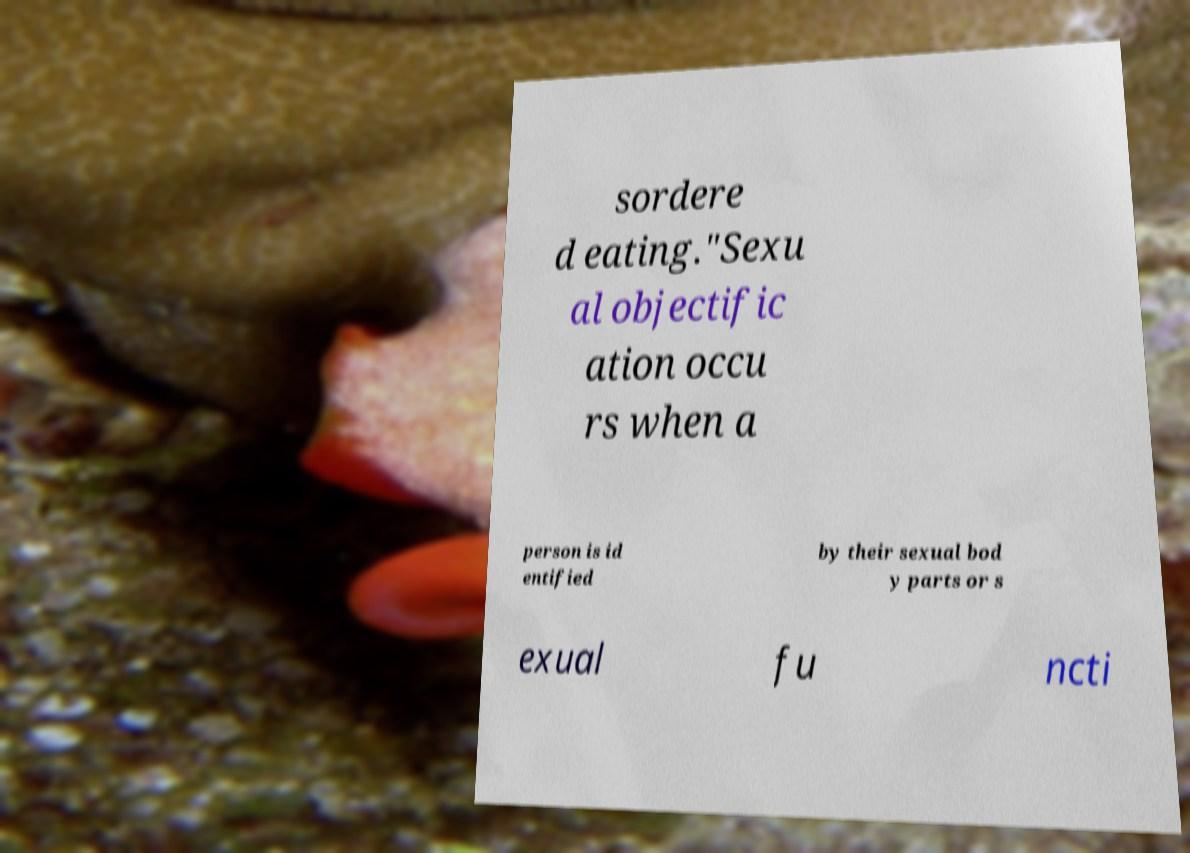Can you read and provide the text displayed in the image?This photo seems to have some interesting text. Can you extract and type it out for me? sordere d eating."Sexu al objectific ation occu rs when a person is id entified by their sexual bod y parts or s exual fu ncti 